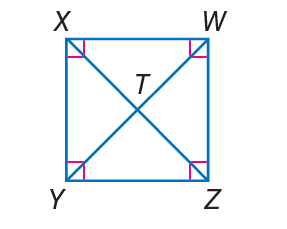Question: W X Y Z is a square. If W T = 3, find Z X.
Choices:
A. 3
B. 5
C. 6
D. 9
Answer with the letter. Answer: C Question: W X Y Z is a square. If W T = 3, find m \angle W T Z.
Choices:
A. 15
B. 30
C. 45
D. 90
Answer with the letter. Answer: D Question: W X Y Z is a square. If W T = 3. Find X Y.
Choices:
A. 3
B. 3 \sqrt { 2 }
C. 6
D. 10
Answer with the letter. Answer: B 